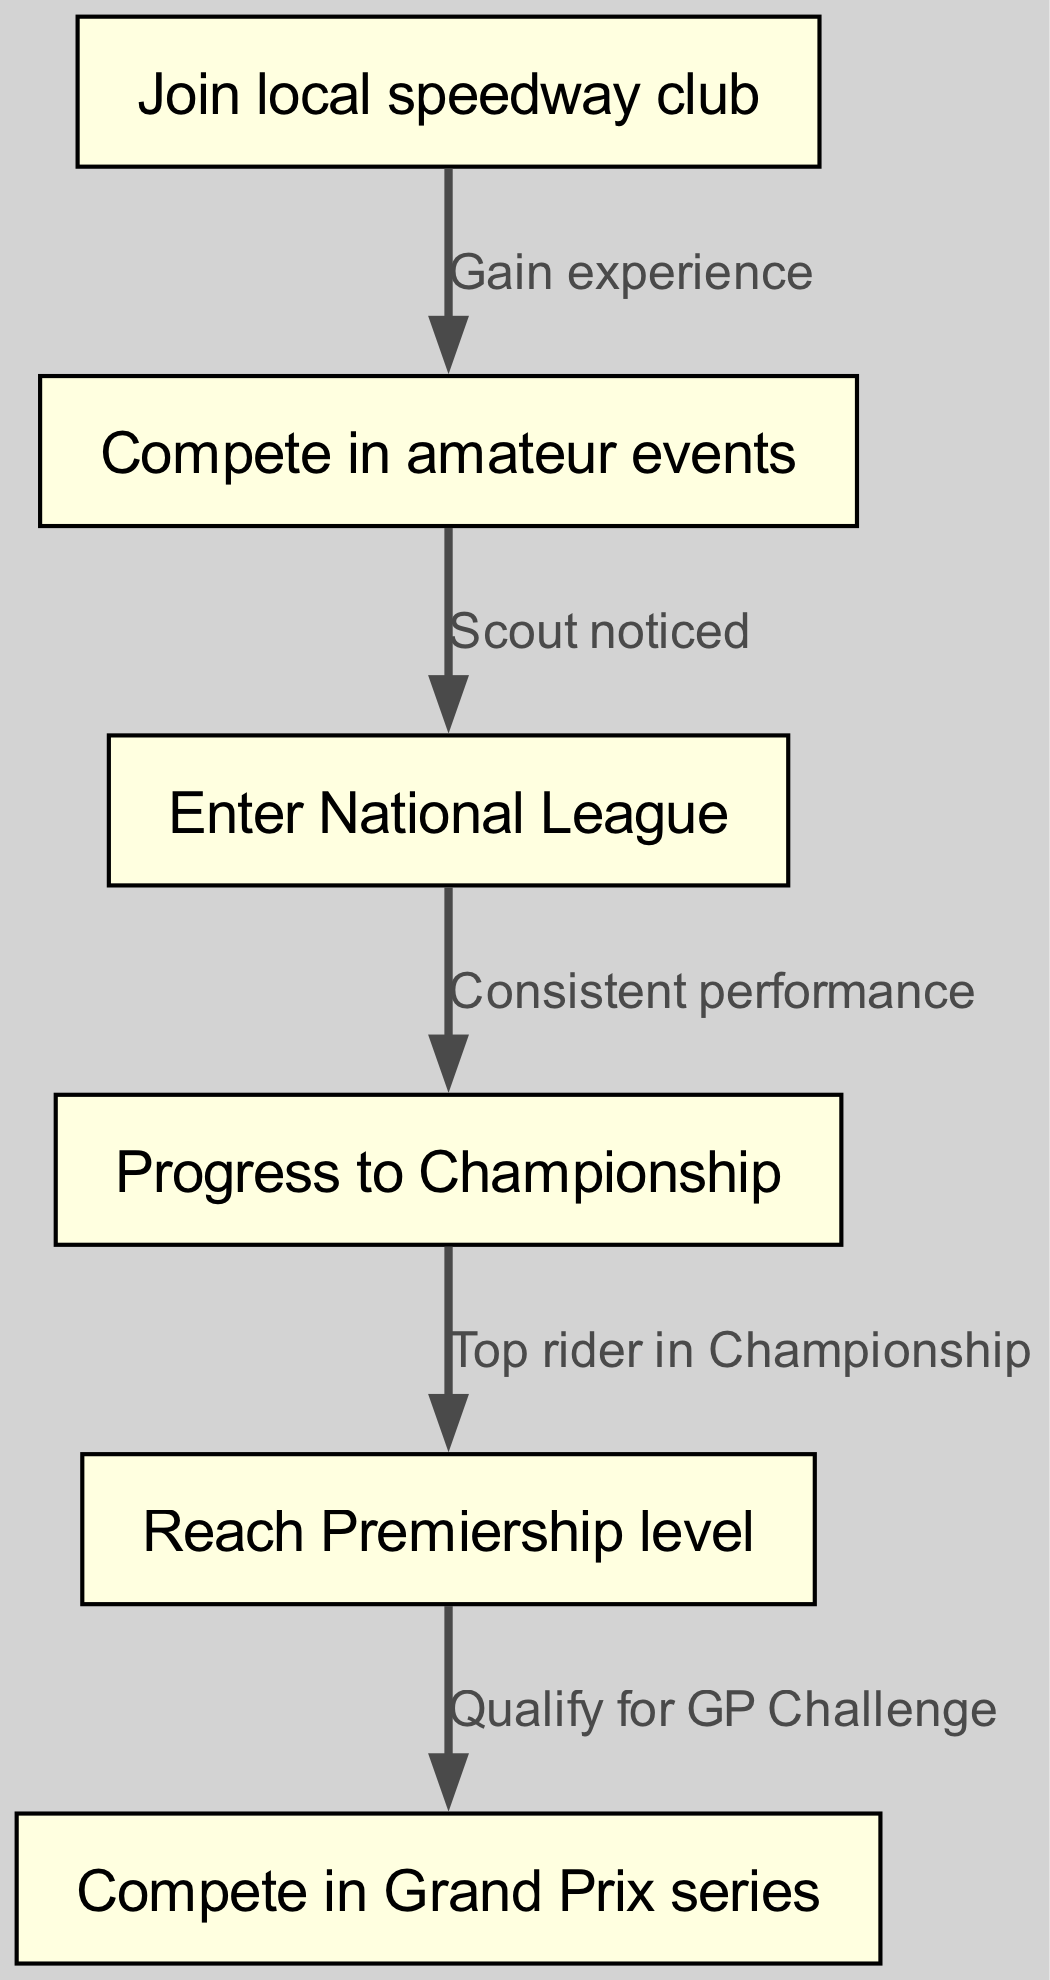What is the first step in the career progression? The diagram shows the first node as "Join local speedway club," which is the initial action for someone starting in speedway racing.
Answer: Join local speedway club How many nodes are present in the diagram? By counting the listed nodes, there are a total of six distinct steps in the career progression from amateur to professional leagues.
Answer: Six What leads to competing in the Grand Prix series? To reach the Grand Prix series, one must first progress to the Premiership level and then qualify for the GP Challenge, which is the direct edge from node five to node six.
Answer: Qualify for GP Challenge Which node represents reaching the Premiership level? The node labeled "Reach Premiership level" represents the stage at which a racer has progressed to the highest national level.
Answer: Reach Premiership level What relationship connects competing in amateur events to entering the National League? The edge connecting the node for competing in amateur events to the National League indicates that a scout noticed the racer during their amateur competitions, prompting their entry into the National League.
Answer: Scout noticed What is necessary for progressing from the National League to the Championship? To move from the National League to the Championship, consistent performance is required, as indicated by the edge leading from node three to node four.
Answer: Consistent performance What is the progression flow from amateur competitions to the Grand Prix series? The flow from amateur competitions starts with joining a local speedway club, then competing in events, entering the National League, progressing through a championship, reaching the Premiership level, and finally qualifying for the Grand Prix series.
Answer: Joining local club to qualifying for GP Challenge How does one transition from the Championship to reaching Premiership level? The transition occurs when a rider becomes a top performer in the Championship, which is indicated by the direct edge from node four to node five.
Answer: Top rider in Championship 